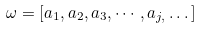Convert formula to latex. <formula><loc_0><loc_0><loc_500><loc_500>\omega = \left [ a _ { 1 } , a _ { 2 } , a _ { 3 } , \cdots , a _ { j , } \dots \right ]</formula> 